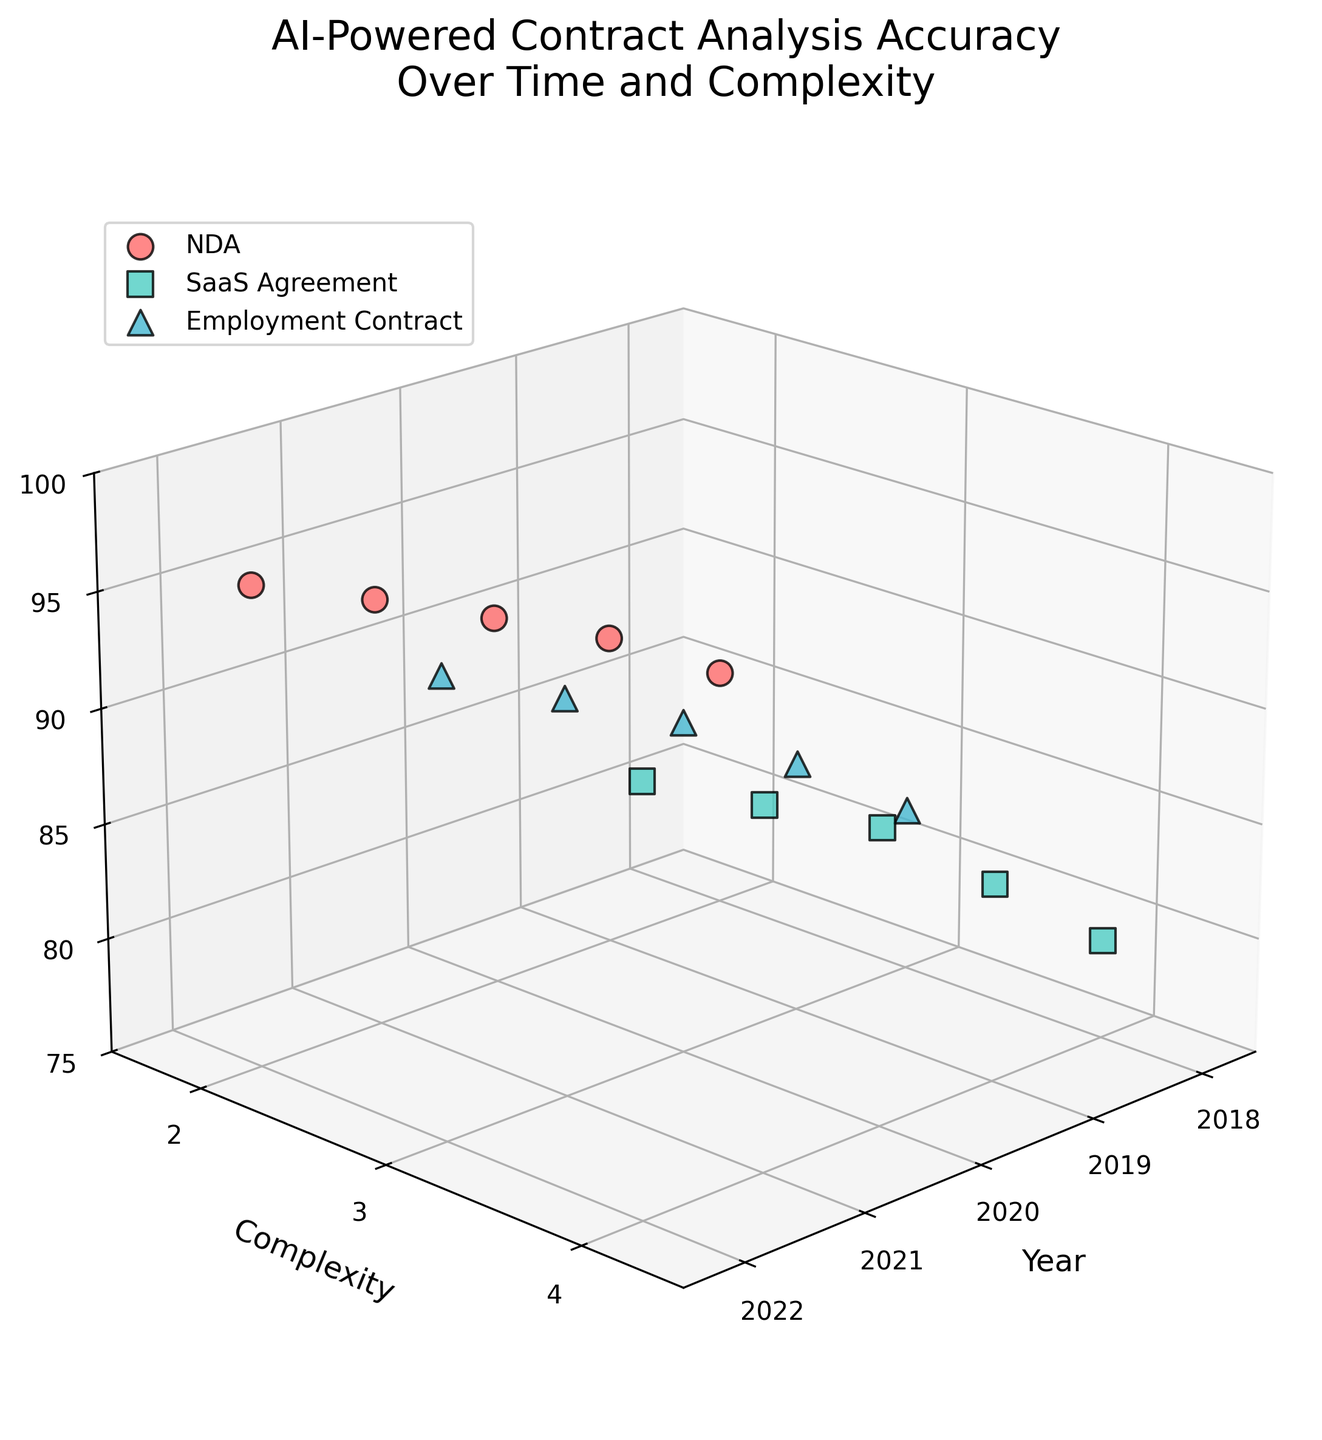What is the title of the figure? The title of the figure is "AI-Powered Contract Analysis Accuracy Over Time and Complexity", it is displayed at the top of the figure in larger font.
Answer: AI-Powered Contract Analysis Accuracy Over Time and Complexity Which contract type had the highest accuracy in 2022? To find the highest accuracy in 2022, look at the 2022 data points on the Accuracy axis (Z-axis) and identify the contract type with the highest value. NDA has the highest accuracy at 95.8%.
Answer: NDA How does the accuracy of Employment Contracts change from 2018 to 2022? Look at the Accuracy (Z-axis) for Employment Contracts for each year from 2018 to 2022. The accuracy increases from 82.1% in 2018 to 94.7% in 2022.
Answer: Increases Which contract type consistently shows the highest accuracy across all years? To determine this, compare the accuracy values for NDA, SaaS Agreement, and Employment Contract from 2018 to 2022. NDA consistently has the highest accuracy.
Answer: NDA What's the relationship between document complexity and accuracy across all years? Examine data points across different complexities (Y-axis) and their corresponding accuracies (Z-axis). Higher complexities show lower accuracies; NDA (complexity 2) maintains the highest accuracy.
Answer: Higher complexity, lower accuracy What is the average accuracy for SaaS Agreements over the years? Calculate the average by summing the Accuracy values for SaaS Agreements from 2018 to 2022 (79.3 + 83.6 + 87.8 + 90.5 + 93.2) and dividing by 5. The sum is 434.4, so the average is 434.4 / 5 = 86.88%.
Answer: 86.88% How has the accuracy of SaaS Agreements improved from 2018 to 2022? To find the improvement, subtract the 2018 accuracy from the 2022 accuracy for SaaS Agreements (93.2% - 79.3% = 13.9%). So, the improvement is 13.9%.
Answer: 13.9% Which year shows the highest overall accuracy for all contract types? Summarize the highest accuracy values of each year across all contract types and compare. The highest accuracy in 2022 has NDA at 95.8%, SaaS Agreement at 93.2%, and Employment Contract at 94.7%, all are higher than previous years, making 2022 the highest overall.
Answer: 2022 What can be inferred about the trend of AI-powered contract analysis accuracy over time? Look at the yearly progression of accuracy values from 2018 to 2022. The trend shows a consistent increase in accuracy over time for all contract types.
Answer: Increasing trend Which contract type saw the greatest improvement in accuracy from 2018 to 2022? Calculate the accuracy change for each contract type by subtracting the 2018 accuracy from the 2022 accuracy: NDA (95.8% - 85.5% = 10.3%), SaaS Agreement (93.2% - 79.3% = 13.9%), and Employment Contract (94.7% - 82.1% = 12.6%). SaaS Agreements saw the greatest improvement.
Answer: SaaS Agreement 